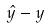Convert formula to latex. <formula><loc_0><loc_0><loc_500><loc_500>\hat { y } - y</formula> 